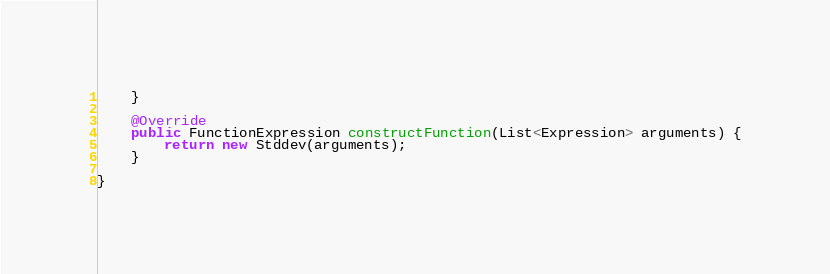Convert code to text. <code><loc_0><loc_0><loc_500><loc_500><_Java_>    }

    @Override
    public FunctionExpression constructFunction(List<Expression> arguments) {
        return new Stddev(arguments);
    }

}
</code> 